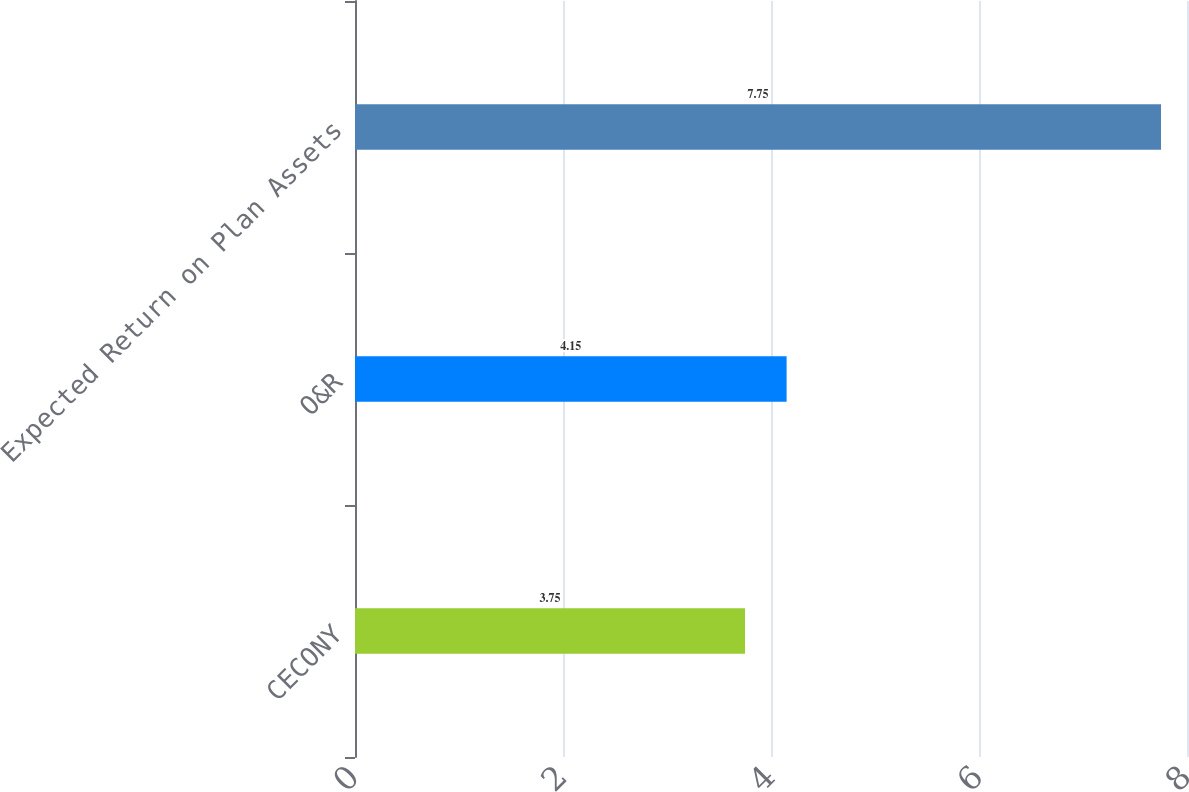Convert chart to OTSL. <chart><loc_0><loc_0><loc_500><loc_500><bar_chart><fcel>CECONY<fcel>O&R<fcel>Expected Return on Plan Assets<nl><fcel>3.75<fcel>4.15<fcel>7.75<nl></chart> 